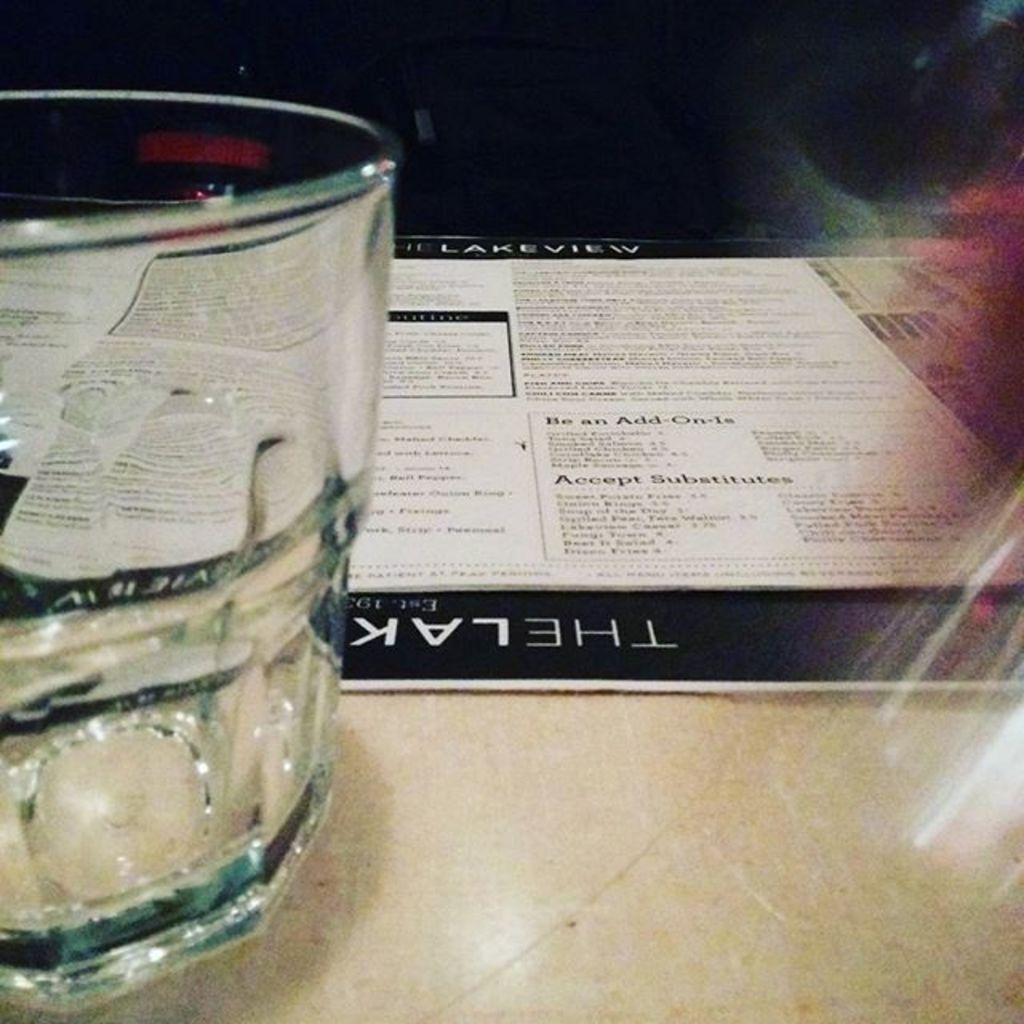<image>
Render a clear and concise summary of the photo. The Lakeview menu with add on and substitutes. 